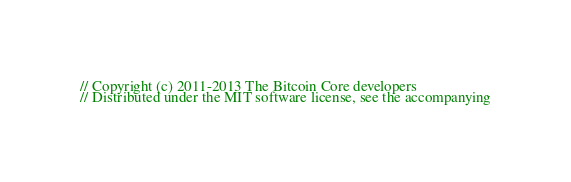<code> <loc_0><loc_0><loc_500><loc_500><_ObjectiveC_>// Copyright (c) 2011-2013 The Bitcoin Core developers
// Distributed under the MIT software license, see the accompanying</code> 